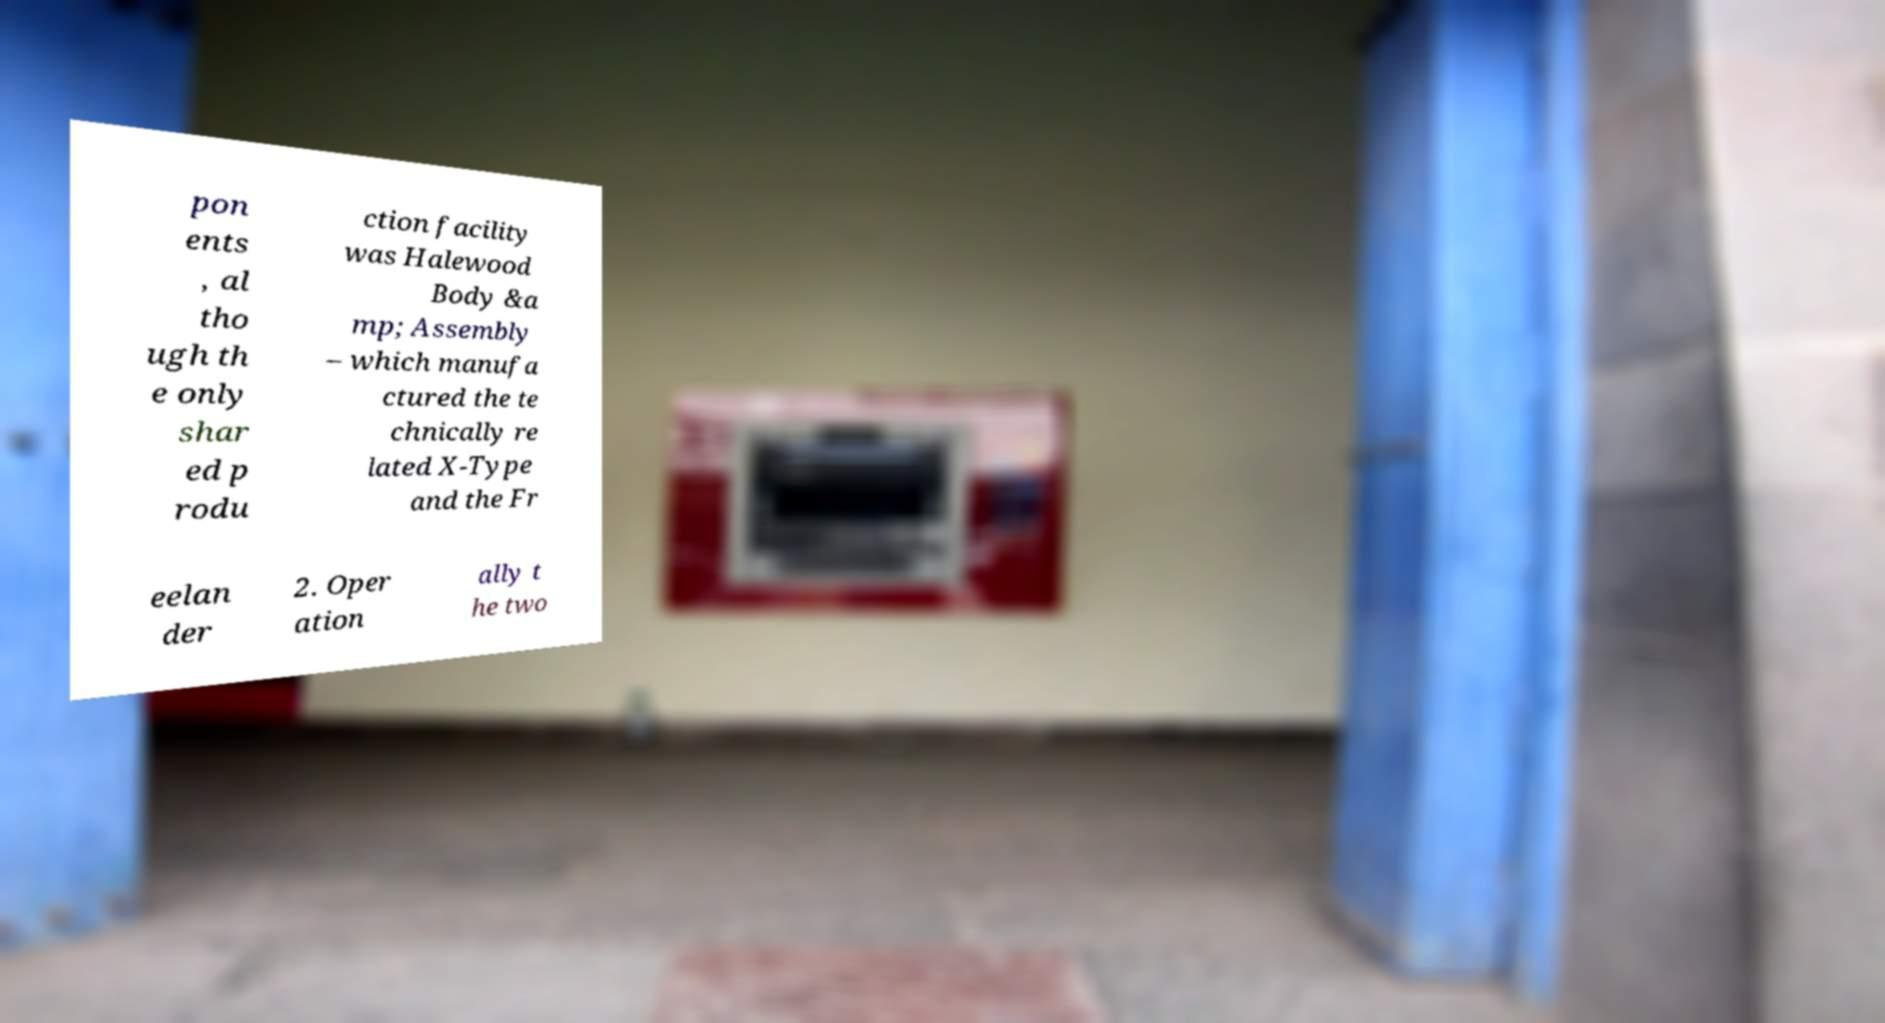What messages or text are displayed in this image? I need them in a readable, typed format. pon ents , al tho ugh th e only shar ed p rodu ction facility was Halewood Body &a mp; Assembly – which manufa ctured the te chnically re lated X-Type and the Fr eelan der 2. Oper ation ally t he two 